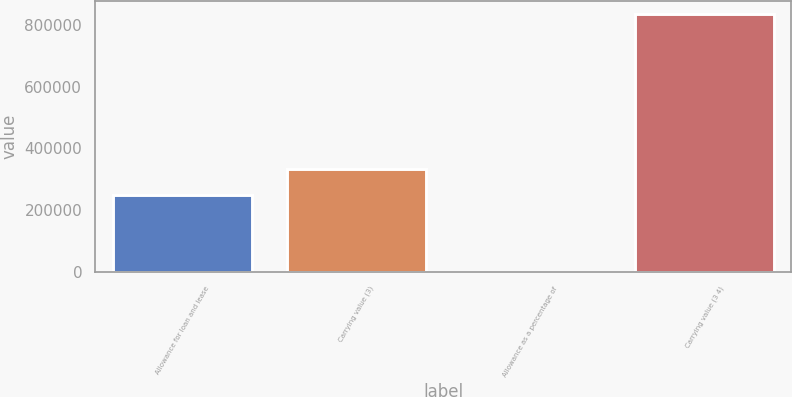<chart> <loc_0><loc_0><loc_500><loc_500><bar_chart><fcel>Allowance for loan and lease<fcel>Carrying value (3)<fcel>Allowance as a percentage of<fcel>Carrying value (3 4)<nl><fcel>250107<fcel>333476<fcel>1.86<fcel>833687<nl></chart> 